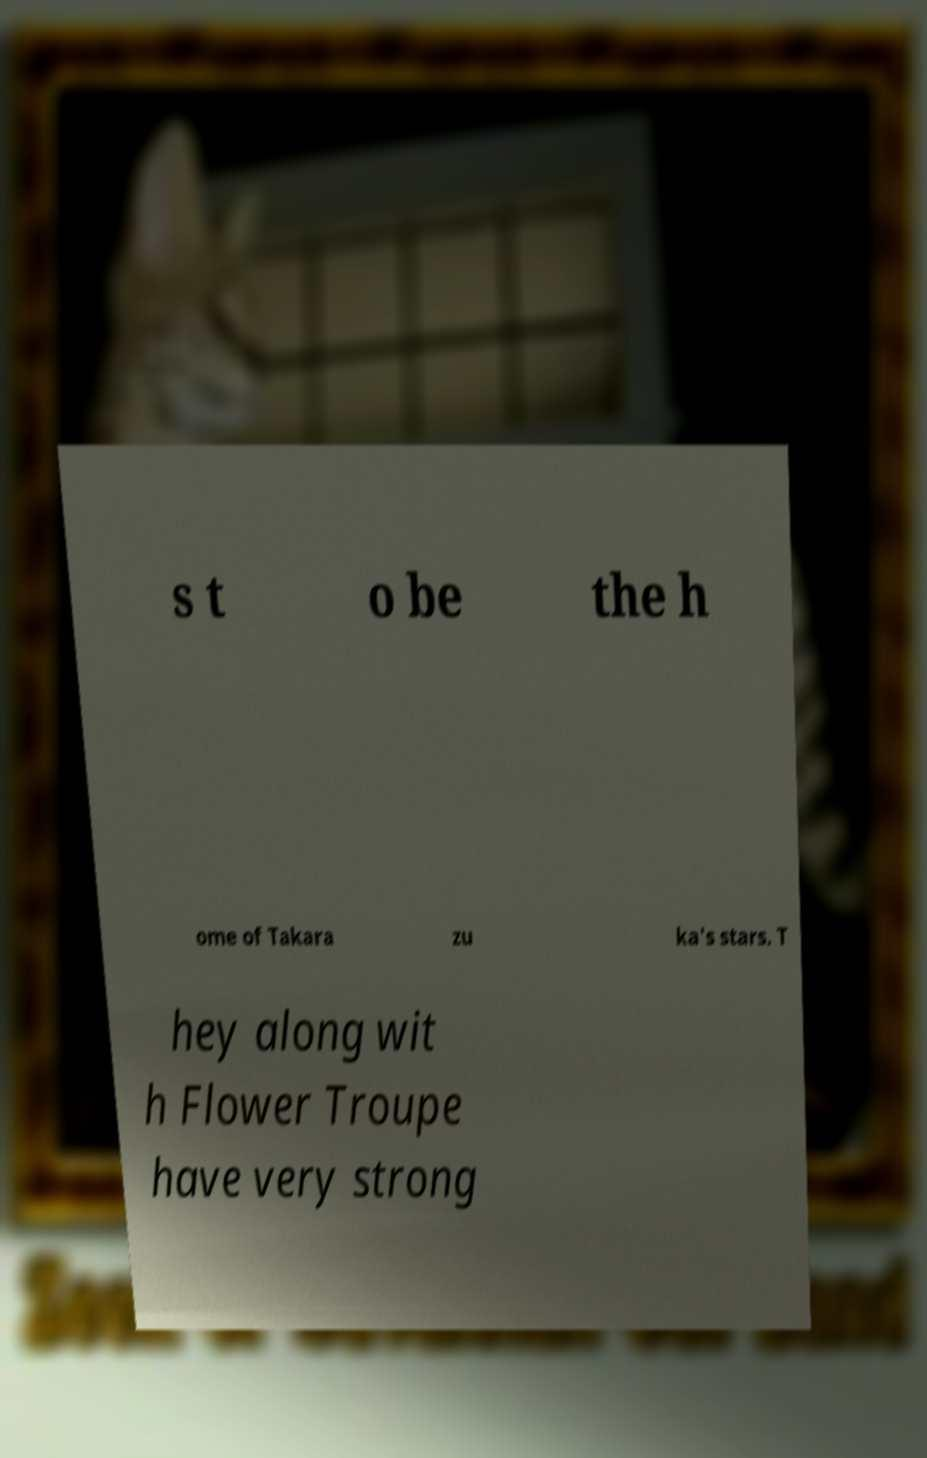Can you read and provide the text displayed in the image?This photo seems to have some interesting text. Can you extract and type it out for me? s t o be the h ome of Takara zu ka's stars. T hey along wit h Flower Troupe have very strong 